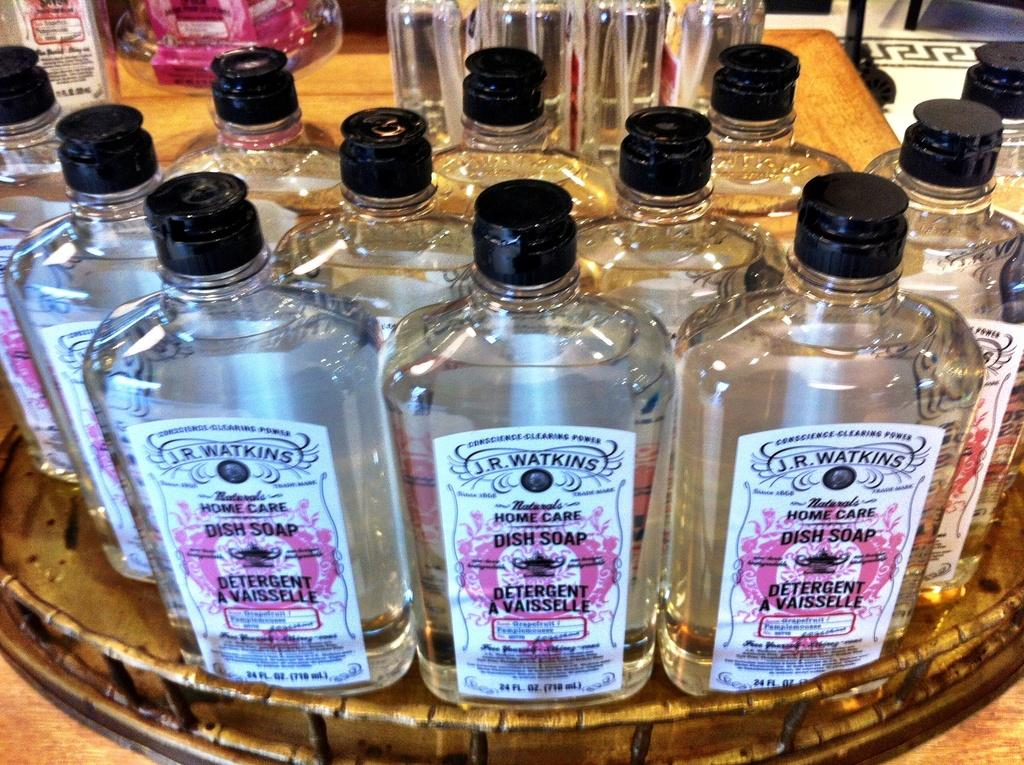<image>
Share a concise interpretation of the image provided. A display of clear bottles of J.R. Watkins dish soap. 